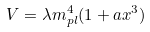Convert formula to latex. <formula><loc_0><loc_0><loc_500><loc_500>V = \lambda m _ { p l } ^ { 4 } ( 1 + a x ^ { 3 } )</formula> 